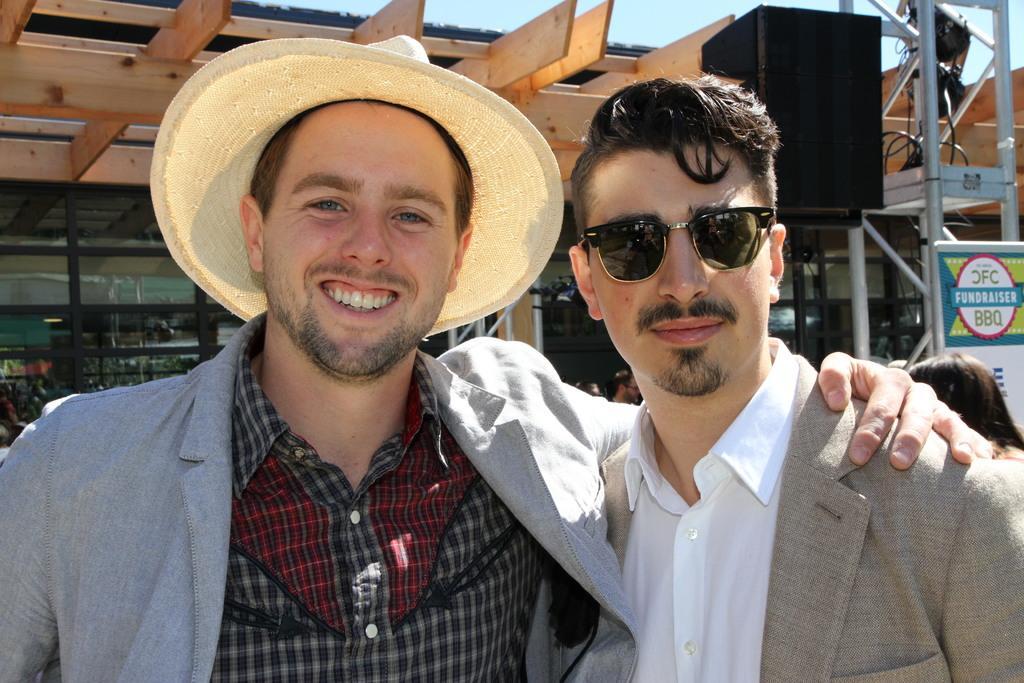Describe this image in one or two sentences. In this picture I can see two men are standing together. The man on the left side is wearing a cap and the man on the right side is wearing glasses. In the background I can see building and sky. 